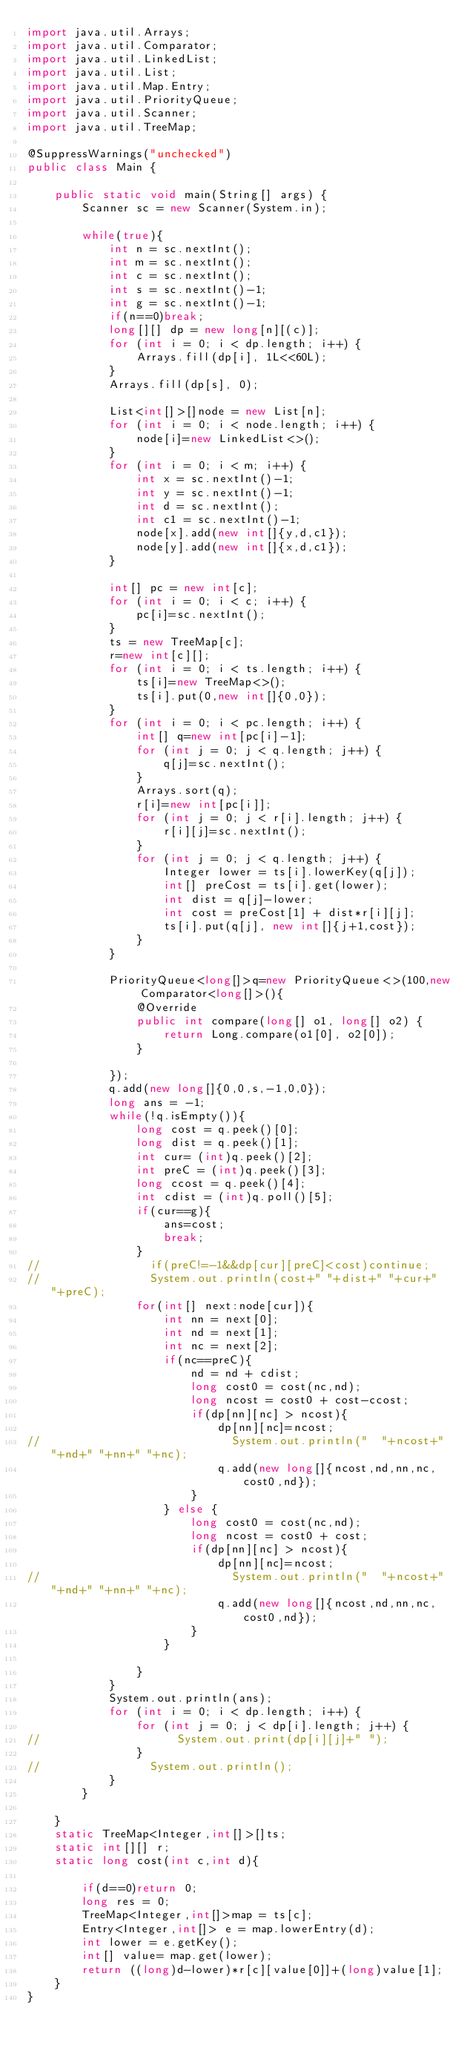Convert code to text. <code><loc_0><loc_0><loc_500><loc_500><_Java_>import java.util.Arrays;
import java.util.Comparator;
import java.util.LinkedList;
import java.util.List;
import java.util.Map.Entry;
import java.util.PriorityQueue;
import java.util.Scanner;
import java.util.TreeMap;

@SuppressWarnings("unchecked")
public class Main {

    public static void main(String[] args) {
        Scanner sc = new Scanner(System.in);

        while(true){
            int n = sc.nextInt();
            int m = sc.nextInt();
            int c = sc.nextInt();
            int s = sc.nextInt()-1;
            int g = sc.nextInt()-1;
            if(n==0)break;
            long[][] dp = new long[n][(c)];
            for (int i = 0; i < dp.length; i++) {
                Arrays.fill(dp[i], 1L<<60L);
            }
            Arrays.fill(dp[s], 0);
            
            List<int[]>[]node = new List[n];
            for (int i = 0; i < node.length; i++) {
                node[i]=new LinkedList<>();
            }
            for (int i = 0; i < m; i++) {
                int x = sc.nextInt()-1;
                int y = sc.nextInt()-1;
                int d = sc.nextInt();
                int c1 = sc.nextInt()-1;
                node[x].add(new int[]{y,d,c1});
                node[y].add(new int[]{x,d,c1});
            }
            
            int[] pc = new int[c];
            for (int i = 0; i < c; i++) {
                pc[i]=sc.nextInt();
            }
            ts = new TreeMap[c];
            r=new int[c][];
            for (int i = 0; i < ts.length; i++) {
                ts[i]=new TreeMap<>();
                ts[i].put(0,new int[]{0,0});
            }
            for (int i = 0; i < pc.length; i++) {
                int[] q=new int[pc[i]-1];
                for (int j = 0; j < q.length; j++) {
                    q[j]=sc.nextInt();
                }
                Arrays.sort(q);
                r[i]=new int[pc[i]];
                for (int j = 0; j < r[i].length; j++) {
                    r[i][j]=sc.nextInt();
                }
                for (int j = 0; j < q.length; j++) {
                    Integer lower = ts[i].lowerKey(q[j]);
                    int[] preCost = ts[i].get(lower);
                    int dist = q[j]-lower;
                    int cost = preCost[1] + dist*r[i][j];
                    ts[i].put(q[j], new int[]{j+1,cost});    
                }
            }
            
            PriorityQueue<long[]>q=new PriorityQueue<>(100,new Comparator<long[]>(){
                @Override
                public int compare(long[] o1, long[] o2) {
                    return Long.compare(o1[0], o2[0]);
                }
                
            });
            q.add(new long[]{0,0,s,-1,0,0});
            long ans = -1;
            while(!q.isEmpty()){
                long cost = q.peek()[0];
                long dist = q.peek()[1];
                int cur= (int)q.peek()[2];
                int preC = (int)q.peek()[3];
                long ccost = q.peek()[4];
                int cdist = (int)q.poll()[5];
                if(cur==g){
                    ans=cost;
                    break;
                }
//                if(preC!=-1&&dp[cur][preC]<cost)continue;
//                System.out.println(cost+" "+dist+" "+cur+" "+preC);
                for(int[] next:node[cur]){
                    int nn = next[0];
                    int nd = next[1];
                    int nc = next[2];
                    if(nc==preC){
                        nd = nd + cdist;
                        long cost0 = cost(nc,nd);
                        long ncost = cost0 + cost-ccost;
                        if(dp[nn][nc] > ncost){
                            dp[nn][nc]=ncost;
//                            System.out.println("  "+ncost+" "+nd+" "+nn+" "+nc);
                            q.add(new long[]{ncost,nd,nn,nc,cost0,nd});
                        }
                    } else {
                        long cost0 = cost(nc,nd);
                        long ncost = cost0 + cost;
                        if(dp[nn][nc] > ncost){
                            dp[nn][nc]=ncost;
//                            System.out.println("  "+ncost+" "+nd+" "+nn+" "+nc);
                            q.add(new long[]{ncost,nd,nn,nc,cost0,nd});
                        }
                    }
                    
                }
            }
            System.out.println(ans);
            for (int i = 0; i < dp.length; i++) {
                for (int j = 0; j < dp[i].length; j++) {
//                    System.out.print(dp[i][j]+" ");
                }
//                System.out.println();
            }
        }

    }
    static TreeMap<Integer,int[]>[]ts;
    static int[][] r;
    static long cost(int c,int d){

        if(d==0)return 0;
        long res = 0;
        TreeMap<Integer,int[]>map = ts[c];
        Entry<Integer,int[]> e = map.lowerEntry(d);
        int lower = e.getKey();
        int[] value= map.get(lower);
        return ((long)d-lower)*r[c][value[0]]+(long)value[1];
    }
}</code> 